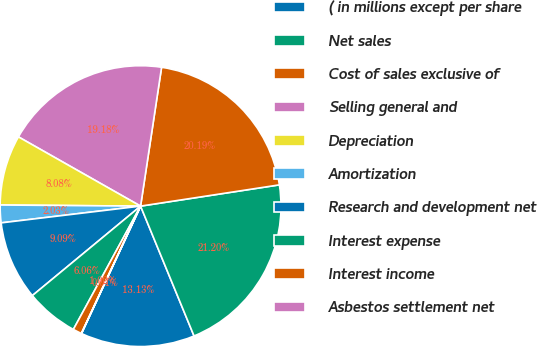<chart> <loc_0><loc_0><loc_500><loc_500><pie_chart><fcel>( in millions except per share<fcel>Net sales<fcel>Cost of sales exclusive of<fcel>Selling general and<fcel>Depreciation<fcel>Amortization<fcel>Research and development net<fcel>Interest expense<fcel>Interest income<fcel>Asbestos settlement net<nl><fcel>13.13%<fcel>21.2%<fcel>20.19%<fcel>19.18%<fcel>8.08%<fcel>2.03%<fcel>9.09%<fcel>6.06%<fcel>1.02%<fcel>0.01%<nl></chart> 